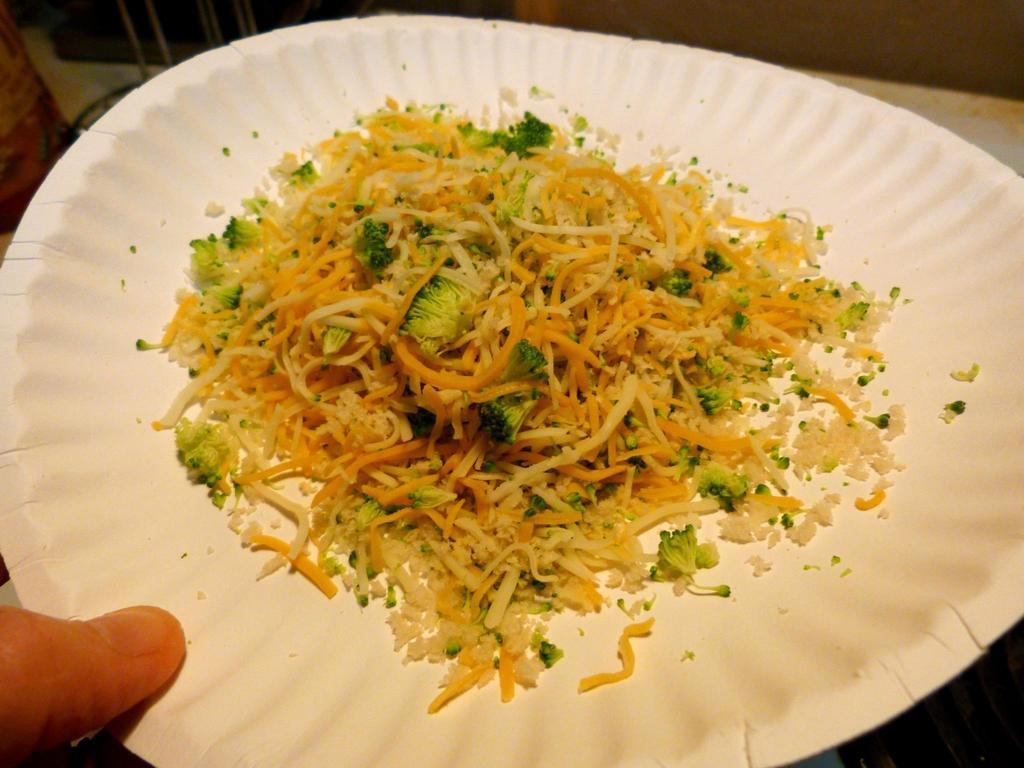What type of food is visible in the image? There are noodles in the image. In what type of dish are the noodles placed? The noodles are placed in a white plate. What type of songs can be heard being sung by the team in the image? There is no team or singing present in the image; it only features noodles placed in a white plate. 